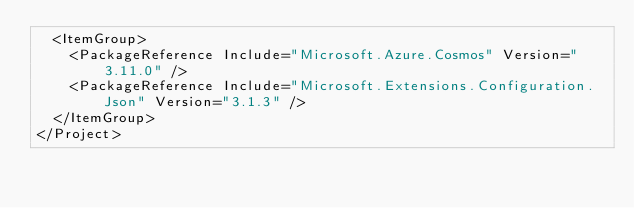Convert code to text. <code><loc_0><loc_0><loc_500><loc_500><_XML_>  <ItemGroup>
    <PackageReference Include="Microsoft.Azure.Cosmos" Version="3.11.0" />
    <PackageReference Include="Microsoft.Extensions.Configuration.Json" Version="3.1.3" />
  </ItemGroup>
</Project>
</code> 